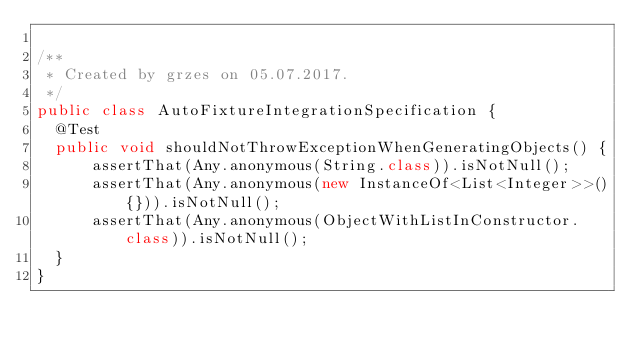<code> <loc_0><loc_0><loc_500><loc_500><_Java_>
/**
 * Created by grzes on 05.07.2017.
 */
public class AutoFixtureIntegrationSpecification {
  @Test
  public void shouldNotThrowExceptionWhenGeneratingObjects() {
      assertThat(Any.anonymous(String.class)).isNotNull();
      assertThat(Any.anonymous(new InstanceOf<List<Integer>>(){})).isNotNull();
      assertThat(Any.anonymous(ObjectWithListInConstructor.class)).isNotNull();
  }
}
</code> 